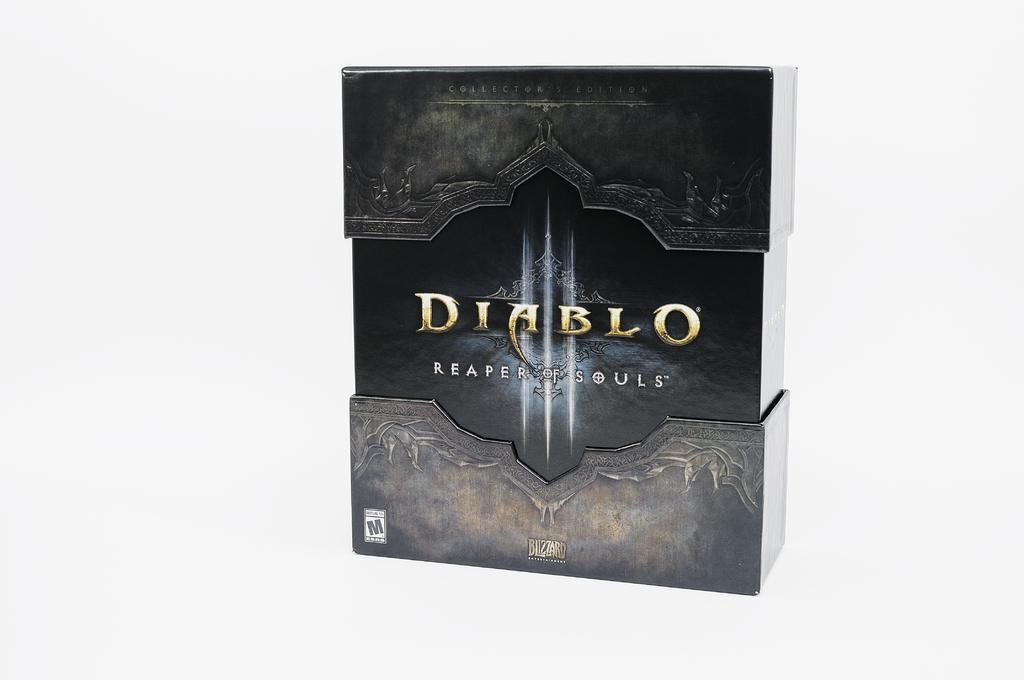Can you describe this image briefly? In the picture we can see a box and it is black in color and written on it as DIABLO reaper of souls and on the box we can see some designs to it. 